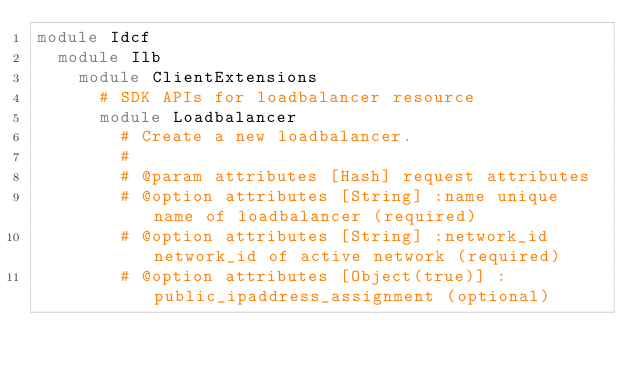<code> <loc_0><loc_0><loc_500><loc_500><_Ruby_>module Idcf
  module Ilb
    module ClientExtensions
      # SDK APIs for loadbalancer resource
      module Loadbalancer
        # Create a new loadbalancer.
        #
        # @param attributes [Hash] request attributes
        # @option attributes [String] :name unique name of loadbalancer (required)
        # @option attributes [String] :network_id network_id of active network (required)
        # @option attributes [Object(true)] :public_ipaddress_assignment (optional)</code> 